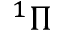<formula> <loc_0><loc_0><loc_500><loc_500>^ { 1 } \Pi</formula> 